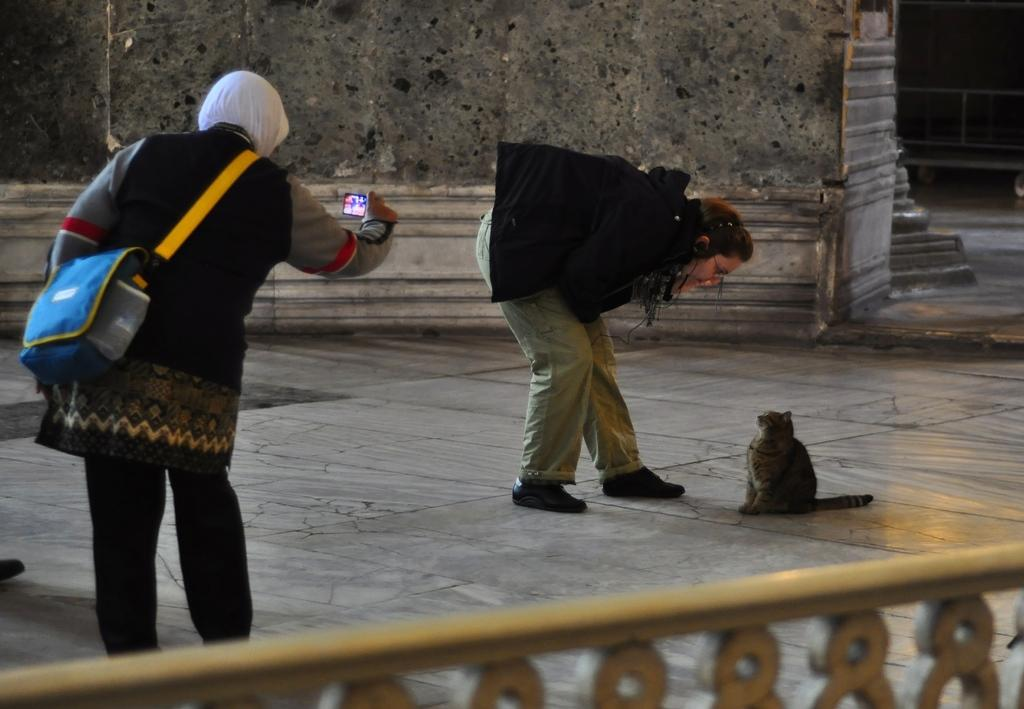What is the lady in the image holding? The lady in the image is holding a camera. What is the lady with the camera doing? The lady with the camera is taking a picture. Can you describe the other lady in the image? The second lady is looking at a cat. How many senses can be seen in the image? There are no senses depicted in the image; it features two ladies and a cat. Is there a church visible in the image? There is no church present in the image. 